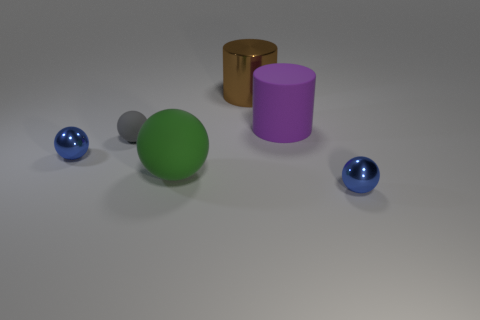Subtract all big green rubber balls. How many balls are left? 3 Add 3 small cyan metal cubes. How many objects exist? 9 Subtract 1 cylinders. How many cylinders are left? 1 Subtract all cylinders. How many objects are left? 4 Subtract all brown cylinders. How many cylinders are left? 1 Subtract all gray blocks. How many blue balls are left? 2 Subtract all rubber cylinders. Subtract all brown metal cylinders. How many objects are left? 4 Add 1 large rubber balls. How many large rubber balls are left? 2 Add 1 big yellow shiny cubes. How many big yellow shiny cubes exist? 1 Subtract 0 gray cylinders. How many objects are left? 6 